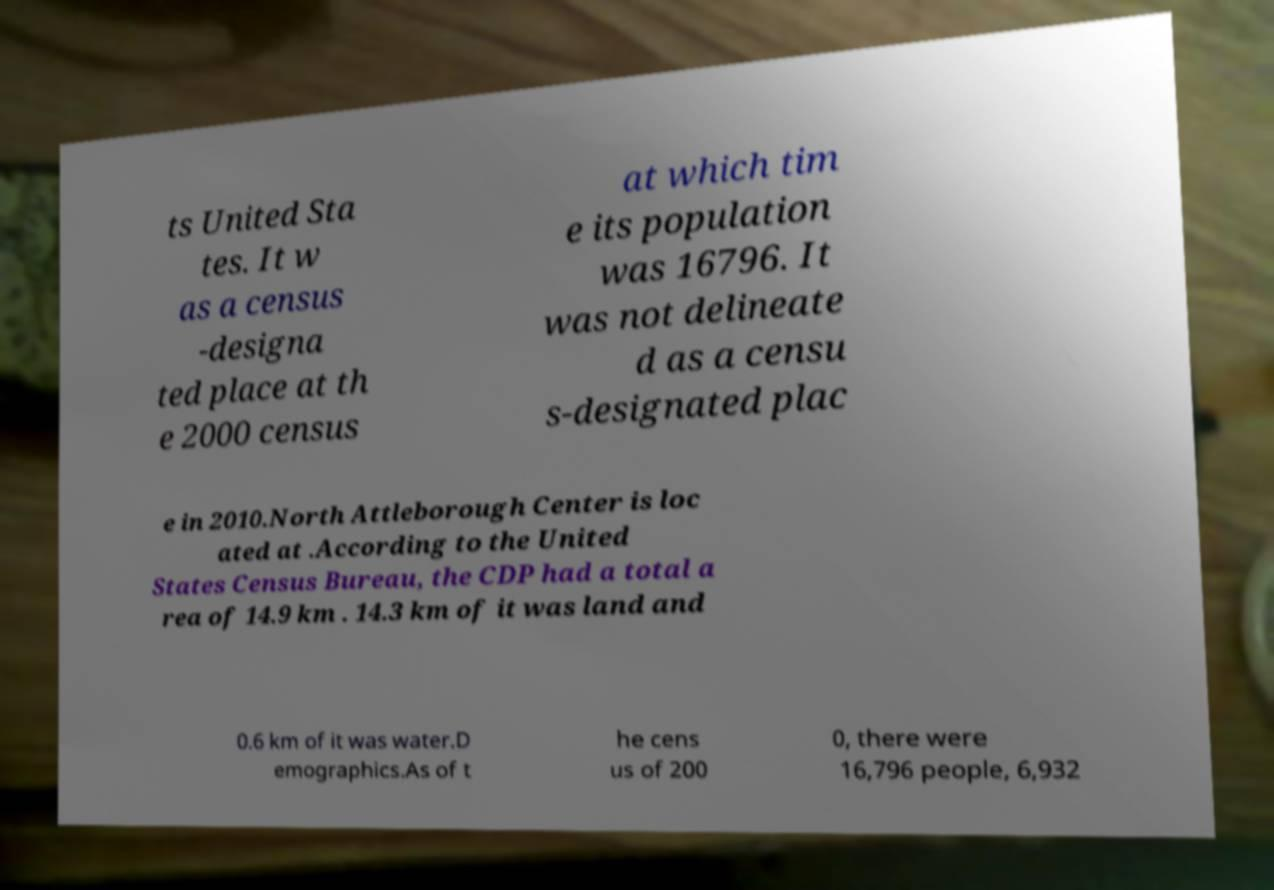There's text embedded in this image that I need extracted. Can you transcribe it verbatim? ts United Sta tes. It w as a census -designa ted place at th e 2000 census at which tim e its population was 16796. It was not delineate d as a censu s-designated plac e in 2010.North Attleborough Center is loc ated at .According to the United States Census Bureau, the CDP had a total a rea of 14.9 km . 14.3 km of it was land and 0.6 km of it was water.D emographics.As of t he cens us of 200 0, there were 16,796 people, 6,932 